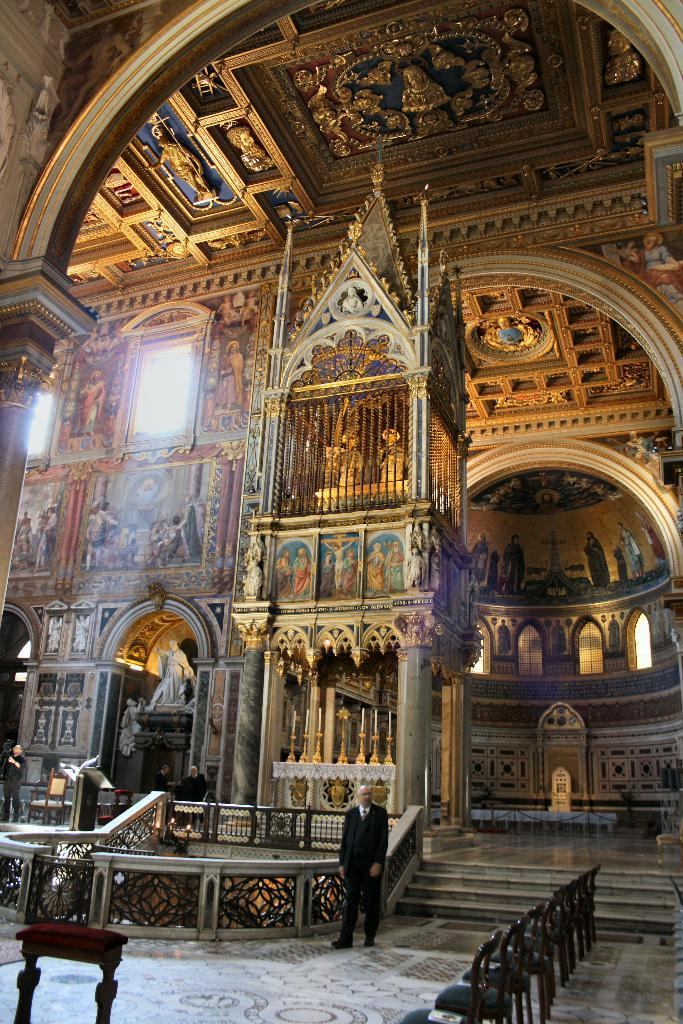What is the main subject of the image? There is a person standing in the image. Where is the person standing? The person is standing on the floor. What can be seen in the background of the image? There is a building in the background of the image. What is covering the building? The building has a photograph of Jesus covering it. What furniture is present in the image? There are chairs and a table in the image. Who is the owner of the building in the image? The facts provided do not mention the owner of the building, so it cannot be determined from the image. --- Facts: 1. There is a person standing in the image. 2. The person is wearing a red shirt. 3. The person is holding a book. 4. The book has a title that reads "The History of...". 5. The person is standing in front of a bookshelf. Absurd Topics: pet, bicycle Conversation: What is the main subject of the image? There is a person standing in the image. What is the person wearing? The person is wearing a red shirt. What is the person holding? The person is holding a book. What can be read from the book's title? The book has a title that reads "The History of...". Where is the person standing? The person is standing in front of a bookshelf. Reasoning: Let's think step by step in order to ${produce the conversation}. We start by identifying the main subject of the image, which is the person standing. Next, we describe the person's clothing, specifically mentioning the red shirt. Then, we observe the action of the person, noting that they are holding a book. After that, we read the title of the book, which is "The History of...". Finally, we describe the person's location, which is in front of a bookshelf. Absurd Question/Answer: Can you see the person's pet in the image? There is no mention of a pet in the image, so it cannot be determined if the person has a pet. 